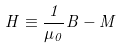<formula> <loc_0><loc_0><loc_500><loc_500>H \equiv \frac { 1 } { \mu _ { 0 } } B - M</formula> 